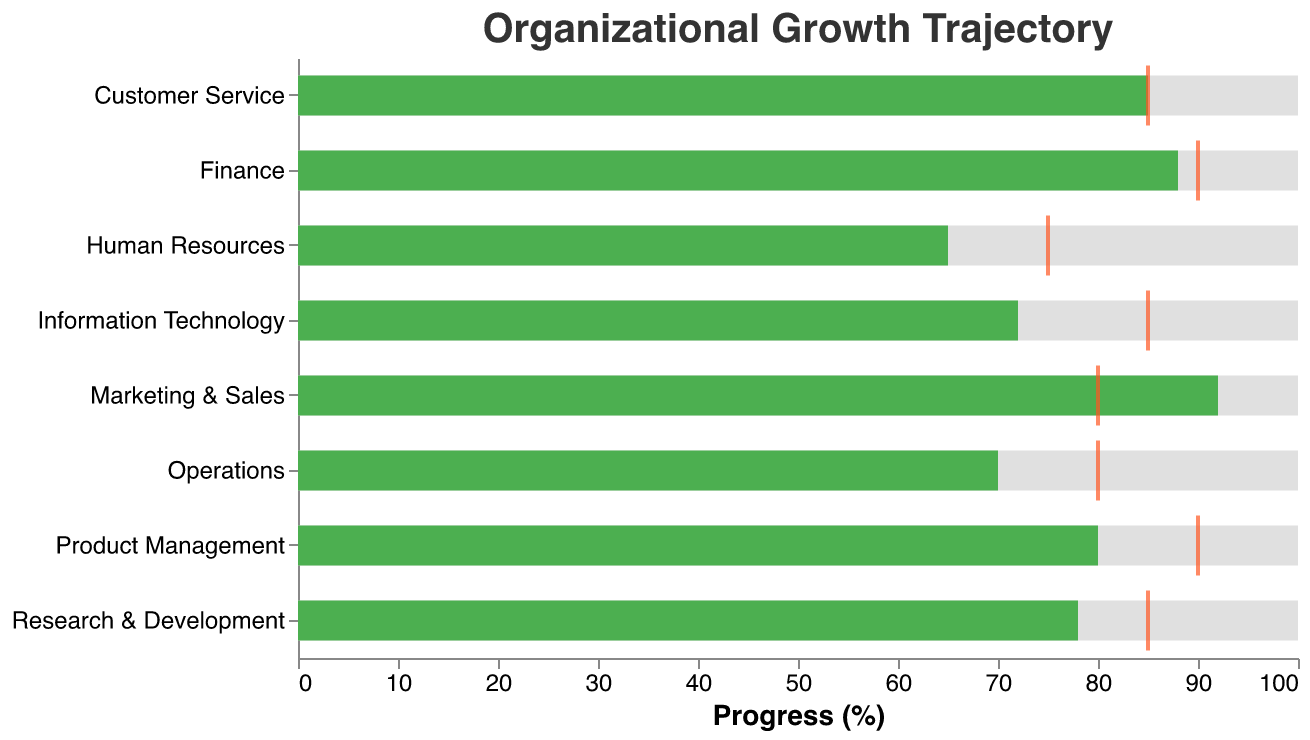What is the title of the chart? The title of the chart is located at the top and indicates what the chart is about.
Answer: Organizational Growth Trajectory Which department has the highest current progress in the chart? The bar that extends the furthest to the right indicates the highest current progress.
Answer: Marketing & Sales What is the target value for the Human Resources department? The target value is indicated by an orange tick mark on the bar for each department.
Answer: 75 Which departments have met or exceeded their target values? By comparing the length of the green bars to the position of the orange tick marks, we can determine which departments have met or exceeded their targets.
Answer: Marketing & Sales, Customer Service What is the difference between the current progress and the target for the Product Management department? Subtract the target value from the current progress value for the Product Management department. 80 (current progress) - 90 (target) = -10
Answer: -10 Which department has the lowest current progress compared to its target value? Calculate the difference between current progress and target for each department and determine which is the smallest. Human Resources: 65-75=-10; Research & Development: 78-85=-7; Operations: 70-80=-10; Information Technology: 72-85=-13
Answer: Information Technology What percentage of departments exceeded their target values? Count the number of departments that have a current progress greater than their target and divide by the total number of departments, then multiply by 100 to get the percentage. (2/8) * 100 = 25%
Answer: 25% Which three departments have the current progress closest to their target values? (disregarding whether they met or exceeded them) Calculate the absolute difference between current progress and target for each department and identify the three smallest differences. Customer Service: 0; Finance: 2; Research & Development: 7
Answer: Customer Service, Finance, Research & Development List the departments in decreasing order of their current progress. Arrange the departments based on the length of the green bars from longest to shortest.
Answer: Marketing & Sales, Finance, Customer Service, Product Management, Research & Development, Information Technology, Operations, Human Resources 